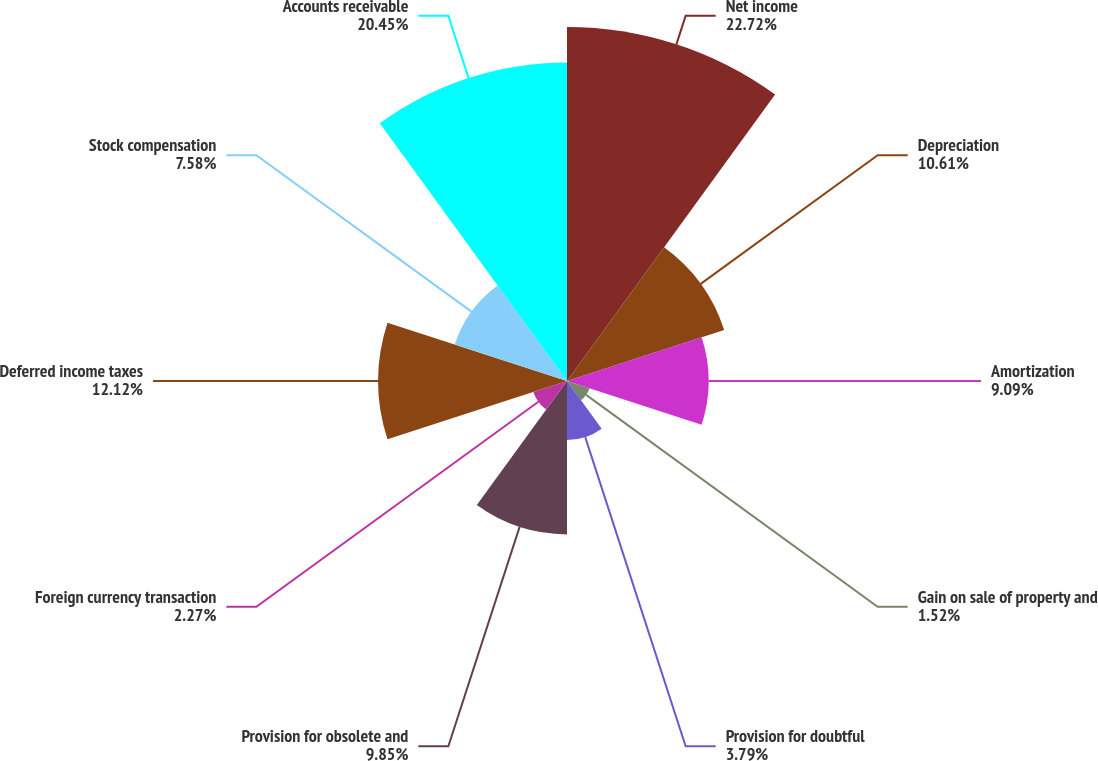Convert chart to OTSL. <chart><loc_0><loc_0><loc_500><loc_500><pie_chart><fcel>Net income<fcel>Depreciation<fcel>Amortization<fcel>Gain on sale of property and<fcel>Provision for doubtful<fcel>Provision for obsolete and<fcel>Foreign currency transaction<fcel>Deferred income taxes<fcel>Stock compensation<fcel>Accounts receivable<nl><fcel>22.73%<fcel>10.61%<fcel>9.09%<fcel>1.52%<fcel>3.79%<fcel>9.85%<fcel>2.27%<fcel>12.12%<fcel>7.58%<fcel>20.45%<nl></chart> 